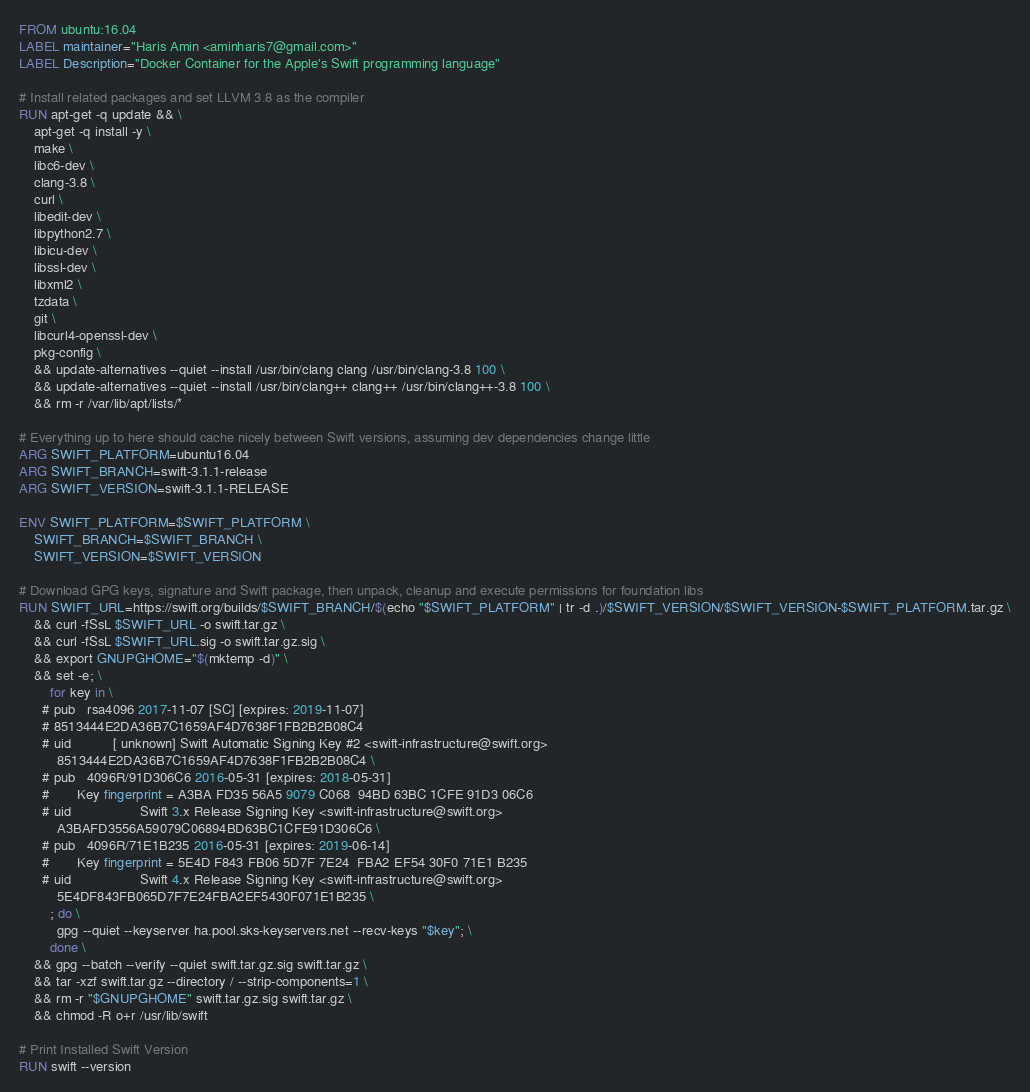Convert code to text. <code><loc_0><loc_0><loc_500><loc_500><_Dockerfile_>FROM ubuntu:16.04
LABEL maintainer="Haris Amin <aminharis7@gmail.com>"
LABEL Description="Docker Container for the Apple's Swift programming language"

# Install related packages and set LLVM 3.8 as the compiler
RUN apt-get -q update && \
    apt-get -q install -y \
    make \
    libc6-dev \
    clang-3.8 \
    curl \
    libedit-dev \
    libpython2.7 \
    libicu-dev \
    libssl-dev \
    libxml2 \
    tzdata \
    git \
    libcurl4-openssl-dev \
    pkg-config \
    && update-alternatives --quiet --install /usr/bin/clang clang /usr/bin/clang-3.8 100 \
    && update-alternatives --quiet --install /usr/bin/clang++ clang++ /usr/bin/clang++-3.8 100 \
    && rm -r /var/lib/apt/lists/*    

# Everything up to here should cache nicely between Swift versions, assuming dev dependencies change little
ARG SWIFT_PLATFORM=ubuntu16.04
ARG SWIFT_BRANCH=swift-3.1.1-release
ARG SWIFT_VERSION=swift-3.1.1-RELEASE

ENV SWIFT_PLATFORM=$SWIFT_PLATFORM \
    SWIFT_BRANCH=$SWIFT_BRANCH \
    SWIFT_VERSION=$SWIFT_VERSION

# Download GPG keys, signature and Swift package, then unpack, cleanup and execute permissions for foundation libs
RUN SWIFT_URL=https://swift.org/builds/$SWIFT_BRANCH/$(echo "$SWIFT_PLATFORM" | tr -d .)/$SWIFT_VERSION/$SWIFT_VERSION-$SWIFT_PLATFORM.tar.gz \
    && curl -fSsL $SWIFT_URL -o swift.tar.gz \
    && curl -fSsL $SWIFT_URL.sig -o swift.tar.gz.sig \
    && export GNUPGHOME="$(mktemp -d)" \
    && set -e; \
        for key in \
      # pub   rsa4096 2017-11-07 [SC] [expires: 2019-11-07]
      # 8513444E2DA36B7C1659AF4D7638F1FB2B2B08C4
      # uid           [ unknown] Swift Automatic Signing Key #2 <swift-infrastructure@swift.org>
          8513444E2DA36B7C1659AF4D7638F1FB2B2B08C4 \
      # pub   4096R/91D306C6 2016-05-31 [expires: 2018-05-31]
      #       Key fingerprint = A3BA FD35 56A5 9079 C068  94BD 63BC 1CFE 91D3 06C6
      # uid                  Swift 3.x Release Signing Key <swift-infrastructure@swift.org>
          A3BAFD3556A59079C06894BD63BC1CFE91D306C6 \
      # pub   4096R/71E1B235 2016-05-31 [expires: 2019-06-14]
      #       Key fingerprint = 5E4D F843 FB06 5D7F 7E24  FBA2 EF54 30F0 71E1 B235
      # uid                  Swift 4.x Release Signing Key <swift-infrastructure@swift.org>          
          5E4DF843FB065D7F7E24FBA2EF5430F071E1B235 \
        ; do \
          gpg --quiet --keyserver ha.pool.sks-keyservers.net --recv-keys "$key"; \
        done \
    && gpg --batch --verify --quiet swift.tar.gz.sig swift.tar.gz \
    && tar -xzf swift.tar.gz --directory / --strip-components=1 \
    && rm -r "$GNUPGHOME" swift.tar.gz.sig swift.tar.gz \
    && chmod -R o+r /usr/lib/swift 

# Print Installed Swift Version
RUN swift --version
</code> 